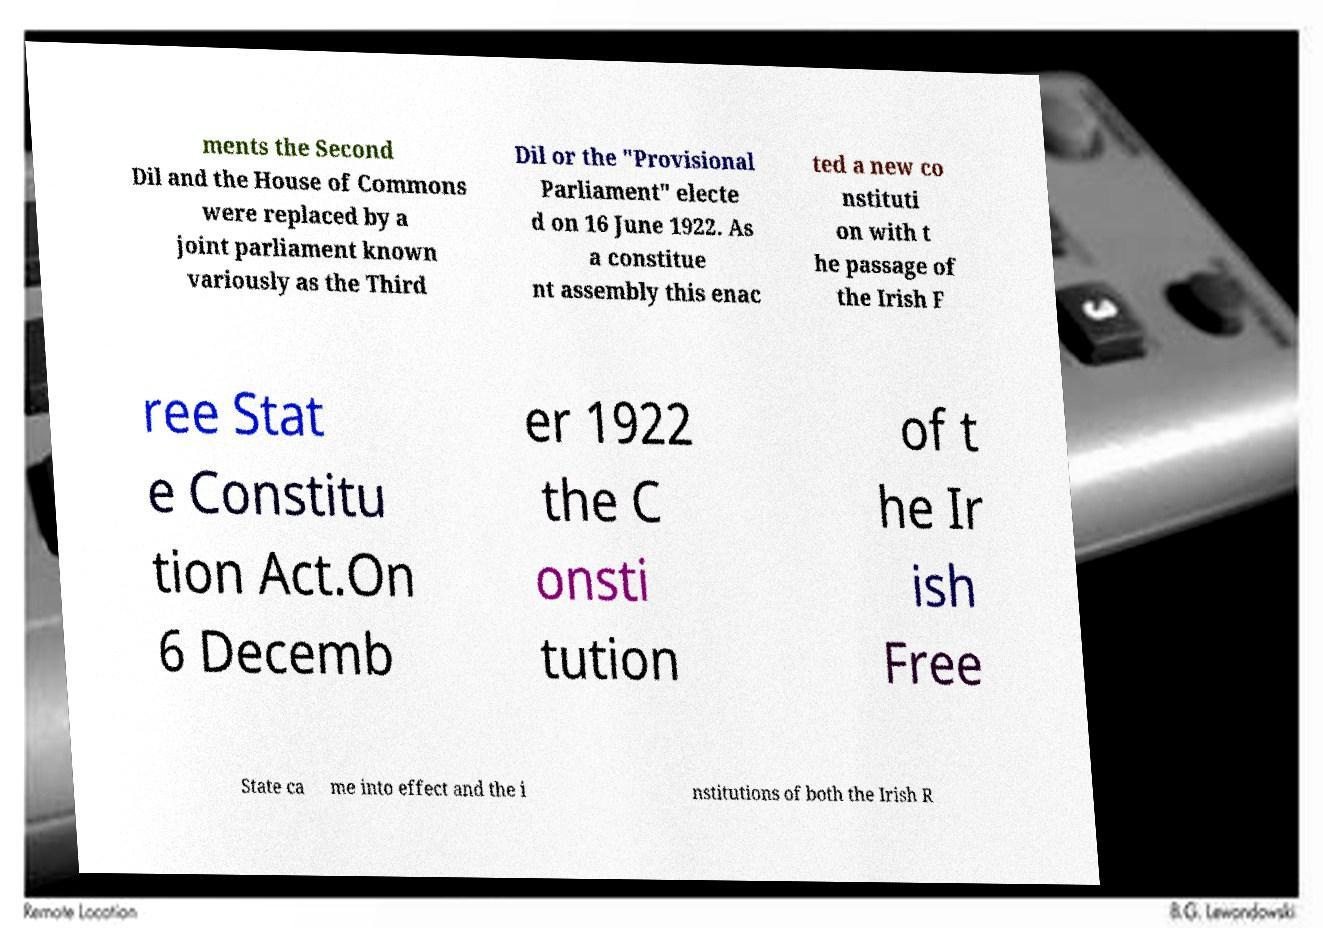I need the written content from this picture converted into text. Can you do that? ments the Second Dil and the House of Commons were replaced by a joint parliament known variously as the Third Dil or the "Provisional Parliament" electe d on 16 June 1922. As a constitue nt assembly this enac ted a new co nstituti on with t he passage of the Irish F ree Stat e Constitu tion Act.On 6 Decemb er 1922 the C onsti tution of t he Ir ish Free State ca me into effect and the i nstitutions of both the Irish R 